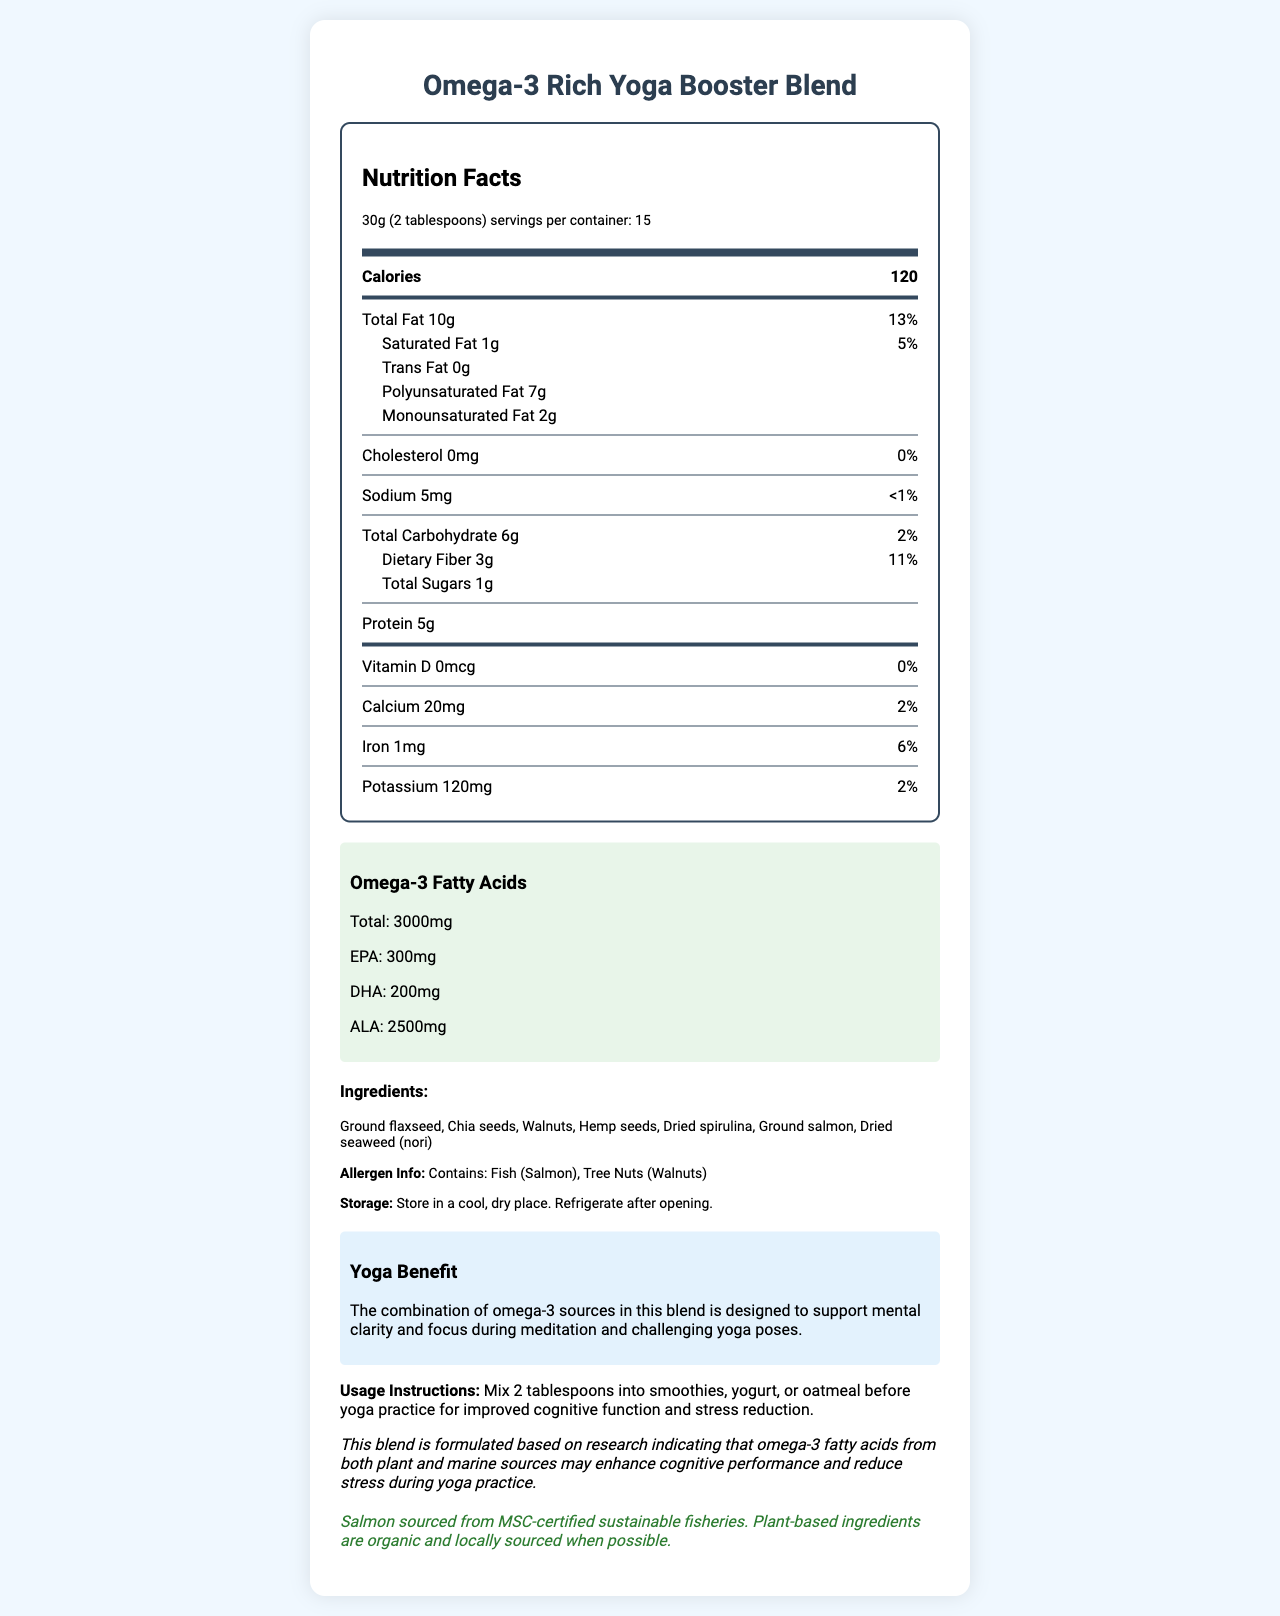what is the total amount of omega-3 fatty acids per serving? The document states in the "Omega-3 Fatty Acids" section that the total amount of omega-3 fatty acids per serving is 3000mg.
Answer: 3000mg what are the main sources of omega-3 fatty acids in this blend? The ingredients section lists these as the components, which are known sources of omega-3 fatty acids.
Answer: Ground flaxseed, Chia seeds, Walnuts, Hemp seeds, Dried spirulina, Ground salmon, Dried seaweed (nori) how many calories are in one serving? The document lists this information near the top in the "Nutrition Facts" section under "Calories."
Answer: 120 what is the daily value percentage for saturated fat? The document provides this in the “Nutrition Facts” section under "Saturated Fat," where it lists the amount as 1g and the daily value as 5%.
Answer: 5% how much protein does one serving contain? The "Nutrition Facts" section specifies that each serving contains 5g of protein.
Answer: 5g Which of the following ingredients is a tree nut? A. Ground flaxseed B. Walnuts C. Dried spirulina D. Hemp seeds The document lists walnuts in the ingredients section, and it also mentions "Tree Nuts (Walnuts)" in the allergen information.
Answer: B what is the primary purpose of the blend according to the document? A. Weight loss B. Improved cognitive function and stress reduction during yoga practice C. Increased muscle mass D. General improved health The document states in the "usage instructions" and "yoga benefit" sections that its purpose is to support improved cognitive function and reduce stress for yoga practice.
Answer: B Is the salmon used in the blend sustainably sourced? Yes/No The "sustainability info" section specifies that the salmon is sourced from MSC-certified sustainable fisheries.
Answer: Yes Summarize the main benefits of the Omega-3 Rich Yoga Booster Blend in one or two sentences. This summary captures the main purpose and benefits of the blend, including its impact on cognitive function, stress reduction, and its sustainable sourcing.
Answer: The Omega-3 Rich Yoga Booster Blend is designed to enhance cognitive function and reduce stress during yoga practice by providing 3000mg of omega-3 fatty acids per serving from both plant and marine sources. Its sustainability and allergen information make it a conscientious choice for those who practice yoga regularly. what is the exact amount of EPA in the blend? The document states in the "Omega-3 Fatty Acids" section that the blend contains 300mg of EPA.
Answer: 300mg How should the Omega-3 Rich Yoga Booster Blend be stored after opening? The "storage" section advises consumers to refrigerate the product after opening.
Answer: Refrigerate after opening Can the exact cognitive benefits of the blend during yoga be found from the document? While the document claims the blend supports mental clarity and stress reduction during yoga practice, it does not provide specific data or studies to substantiate the exact cognitive benefits.
Answer: Not enough information 